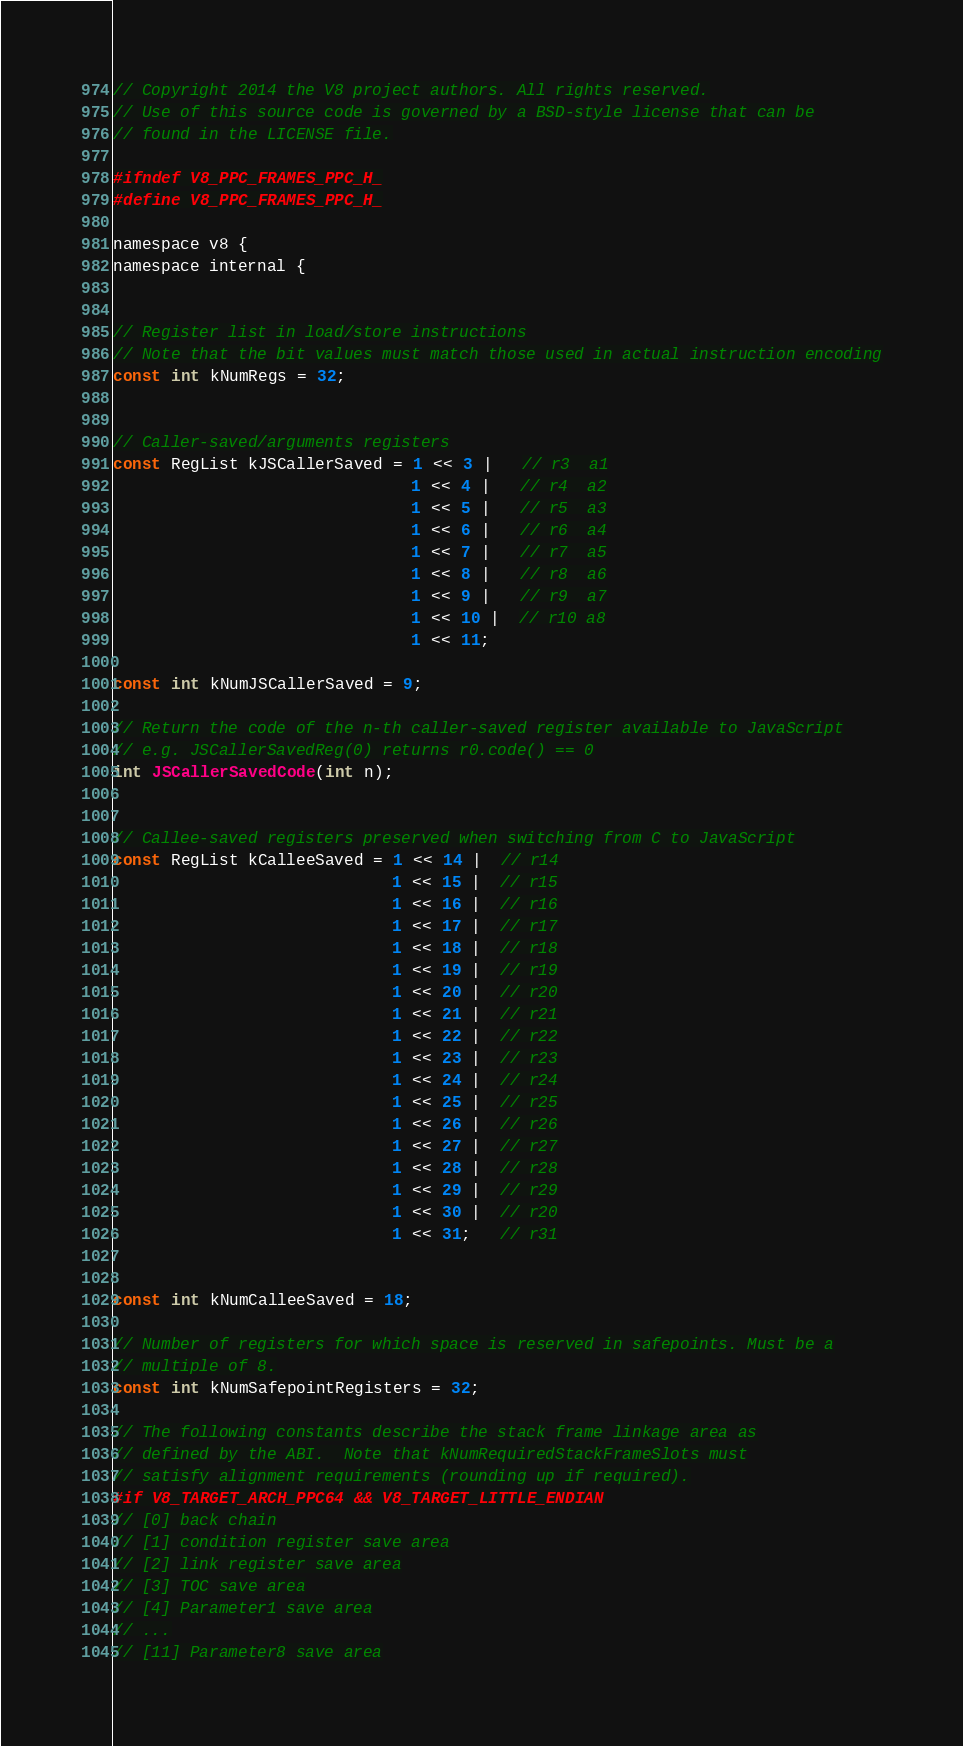<code> <loc_0><loc_0><loc_500><loc_500><_C_>// Copyright 2014 the V8 project authors. All rights reserved.
// Use of this source code is governed by a BSD-style license that can be
// found in the LICENSE file.

#ifndef V8_PPC_FRAMES_PPC_H_
#define V8_PPC_FRAMES_PPC_H_

namespace v8 {
namespace internal {


// Register list in load/store instructions
// Note that the bit values must match those used in actual instruction encoding
const int kNumRegs = 32;


// Caller-saved/arguments registers
const RegList kJSCallerSaved = 1 << 3 |   // r3  a1
                               1 << 4 |   // r4  a2
                               1 << 5 |   // r5  a3
                               1 << 6 |   // r6  a4
                               1 << 7 |   // r7  a5
                               1 << 8 |   // r8  a6
                               1 << 9 |   // r9  a7
                               1 << 10 |  // r10 a8
                               1 << 11;

const int kNumJSCallerSaved = 9;

// Return the code of the n-th caller-saved register available to JavaScript
// e.g. JSCallerSavedReg(0) returns r0.code() == 0
int JSCallerSavedCode(int n);


// Callee-saved registers preserved when switching from C to JavaScript
const RegList kCalleeSaved = 1 << 14 |  // r14
                             1 << 15 |  // r15
                             1 << 16 |  // r16
                             1 << 17 |  // r17
                             1 << 18 |  // r18
                             1 << 19 |  // r19
                             1 << 20 |  // r20
                             1 << 21 |  // r21
                             1 << 22 |  // r22
                             1 << 23 |  // r23
                             1 << 24 |  // r24
                             1 << 25 |  // r25
                             1 << 26 |  // r26
                             1 << 27 |  // r27
                             1 << 28 |  // r28
                             1 << 29 |  // r29
                             1 << 30 |  // r20
                             1 << 31;   // r31


const int kNumCalleeSaved = 18;

// Number of registers for which space is reserved in safepoints. Must be a
// multiple of 8.
const int kNumSafepointRegisters = 32;

// The following constants describe the stack frame linkage area as
// defined by the ABI.  Note that kNumRequiredStackFrameSlots must
// satisfy alignment requirements (rounding up if required).
#if V8_TARGET_ARCH_PPC64 && V8_TARGET_LITTLE_ENDIAN
// [0] back chain
// [1] condition register save area
// [2] link register save area
// [3] TOC save area
// [4] Parameter1 save area
// ...
// [11] Parameter8 save area</code> 